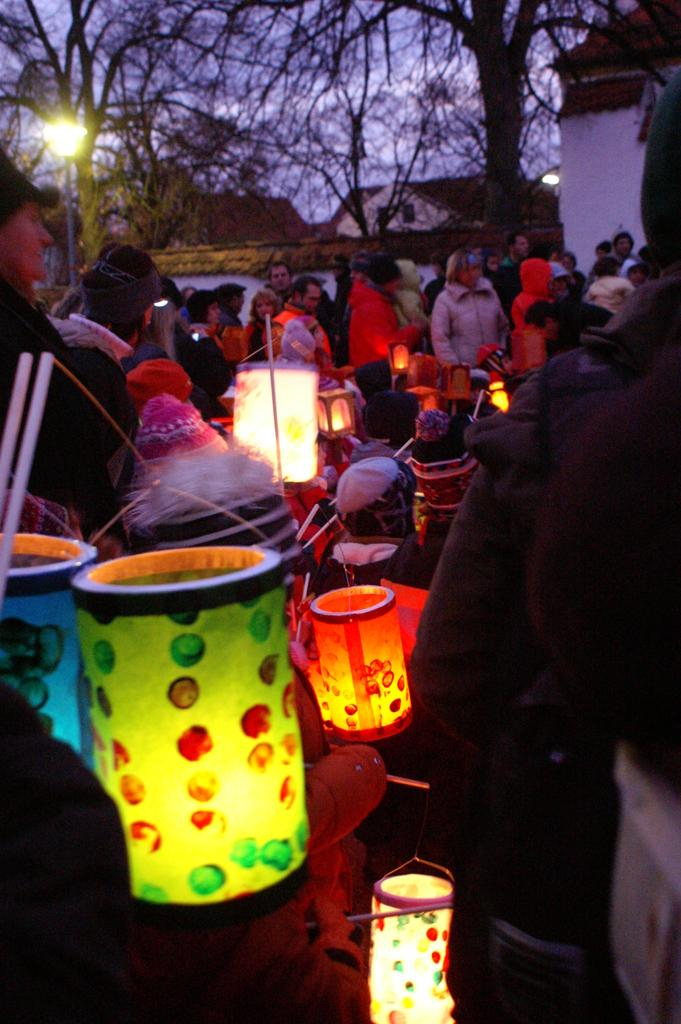What are the people in the image doing? Some people are standing and some are seated in the image. What type of structures can be seen in the image? There are houses visible in the image. What type of vegetation is present in the image? There are trees in the image. What type of lighting is present in the image? There is a pole light in the image. What type of clothing can be seen on some people in the image? Some people are wearing work caps in the image. What type of jeans is the band wearing in the image? There is no band present in the image, and therefore no one is wearing jeans. 